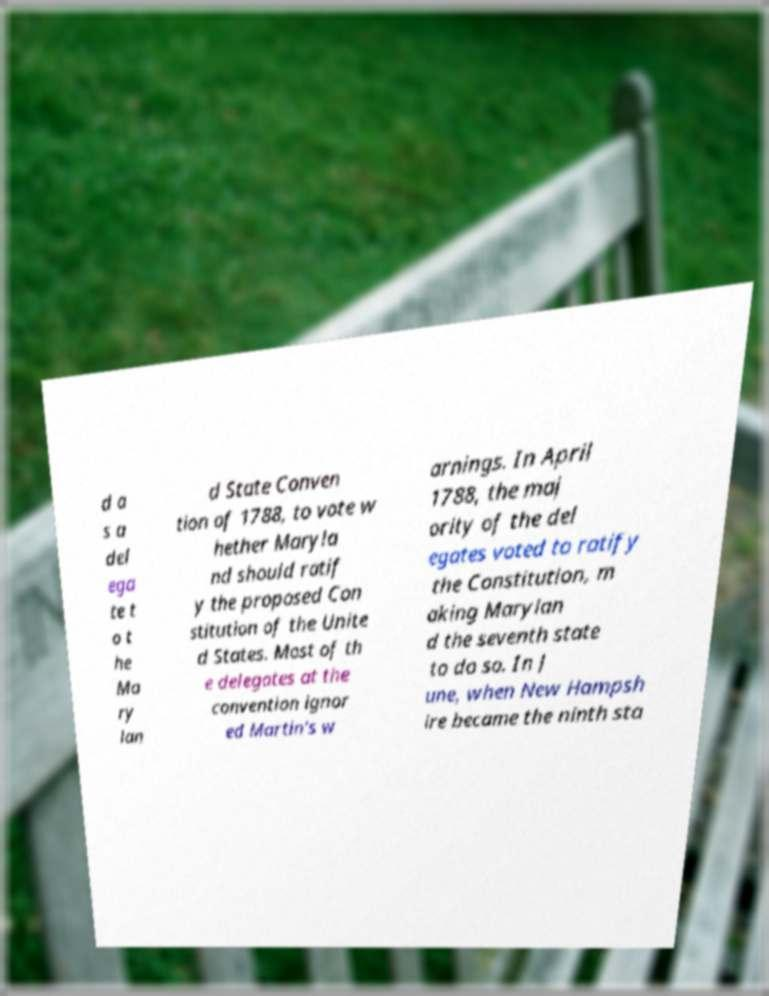There's text embedded in this image that I need extracted. Can you transcribe it verbatim? d a s a del ega te t o t he Ma ry lan d State Conven tion of 1788, to vote w hether Maryla nd should ratif y the proposed Con stitution of the Unite d States. Most of th e delegates at the convention ignor ed Martin's w arnings. In April 1788, the maj ority of the del egates voted to ratify the Constitution, m aking Marylan d the seventh state to do so. In J une, when New Hampsh ire became the ninth sta 